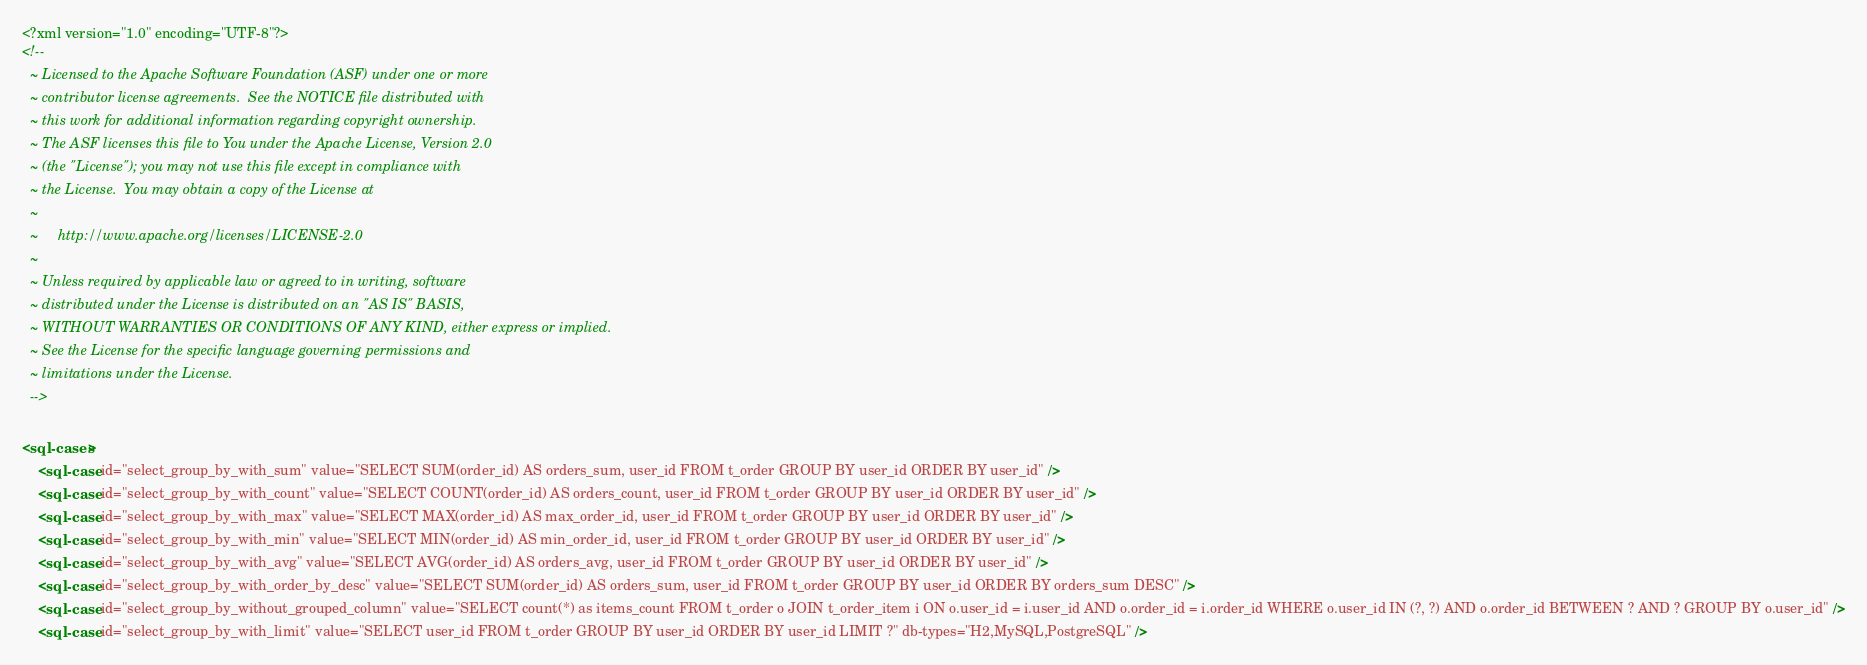<code> <loc_0><loc_0><loc_500><loc_500><_XML_><?xml version="1.0" encoding="UTF-8"?>
<!--
  ~ Licensed to the Apache Software Foundation (ASF) under one or more
  ~ contributor license agreements.  See the NOTICE file distributed with
  ~ this work for additional information regarding copyright ownership.
  ~ The ASF licenses this file to You under the Apache License, Version 2.0
  ~ (the "License"); you may not use this file except in compliance with
  ~ the License.  You may obtain a copy of the License at
  ~
  ~     http://www.apache.org/licenses/LICENSE-2.0
  ~
  ~ Unless required by applicable law or agreed to in writing, software
  ~ distributed under the License is distributed on an "AS IS" BASIS,
  ~ WITHOUT WARRANTIES OR CONDITIONS OF ANY KIND, either express or implied.
  ~ See the License for the specific language governing permissions and
  ~ limitations under the License.
  -->

<sql-cases>
    <sql-case id="select_group_by_with_sum" value="SELECT SUM(order_id) AS orders_sum, user_id FROM t_order GROUP BY user_id ORDER BY user_id" />
    <sql-case id="select_group_by_with_count" value="SELECT COUNT(order_id) AS orders_count, user_id FROM t_order GROUP BY user_id ORDER BY user_id" />
    <sql-case id="select_group_by_with_max" value="SELECT MAX(order_id) AS max_order_id, user_id FROM t_order GROUP BY user_id ORDER BY user_id" />
    <sql-case id="select_group_by_with_min" value="SELECT MIN(order_id) AS min_order_id, user_id FROM t_order GROUP BY user_id ORDER BY user_id" />
    <sql-case id="select_group_by_with_avg" value="SELECT AVG(order_id) AS orders_avg, user_id FROM t_order GROUP BY user_id ORDER BY user_id" />
    <sql-case id="select_group_by_with_order_by_desc" value="SELECT SUM(order_id) AS orders_sum, user_id FROM t_order GROUP BY user_id ORDER BY orders_sum DESC" />
    <sql-case id="select_group_by_without_grouped_column" value="SELECT count(*) as items_count FROM t_order o JOIN t_order_item i ON o.user_id = i.user_id AND o.order_id = i.order_id WHERE o.user_id IN (?, ?) AND o.order_id BETWEEN ? AND ? GROUP BY o.user_id" />
    <sql-case id="select_group_by_with_limit" value="SELECT user_id FROM t_order GROUP BY user_id ORDER BY user_id LIMIT ?" db-types="H2,MySQL,PostgreSQL" /></code> 